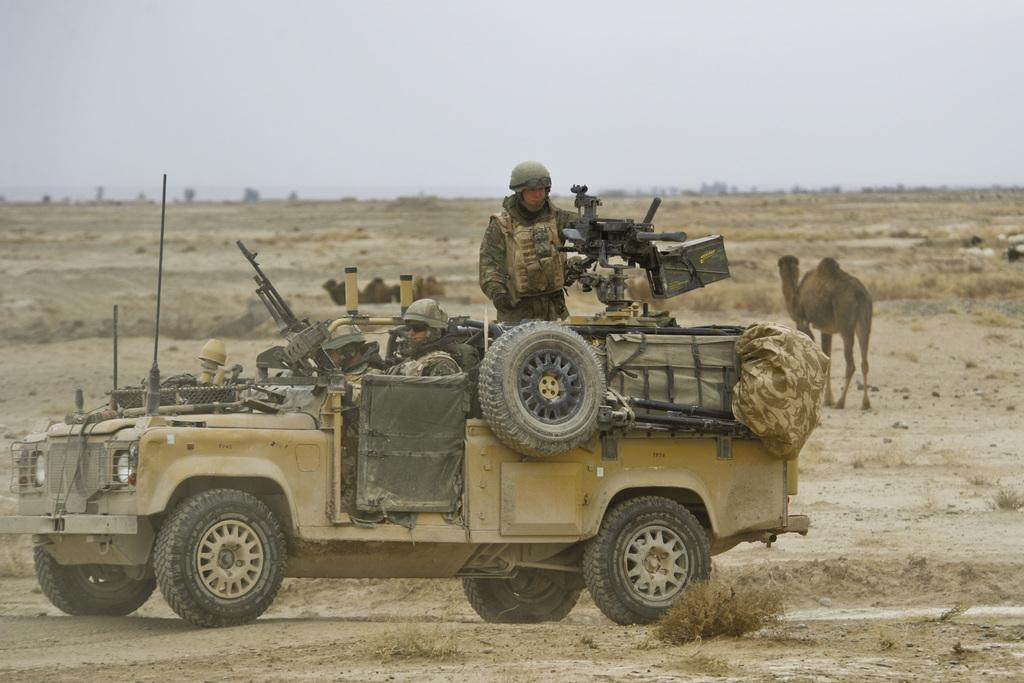What is the main subject in the center of the image? There is a jeep in the center of the image. Who or what is inside the jeep? There are soldiers in the jeep. What are the soldiers holding? The soldiers are holding guns. What can be seen in the background of the image? There are camels in the background of the image. What type of attraction can be seen on the shelf in the image? There is no attraction or shelf present in the image. What is the level of peace depicted in the image? The presence of soldiers and guns suggests that the image does not depict a peaceful situation. 